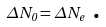<formula> <loc_0><loc_0><loc_500><loc_500>\Delta N _ { 0 } = \Delta N _ { e } \text { .}</formula> 